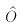Convert formula to latex. <formula><loc_0><loc_0><loc_500><loc_500>\hat { O }</formula> 